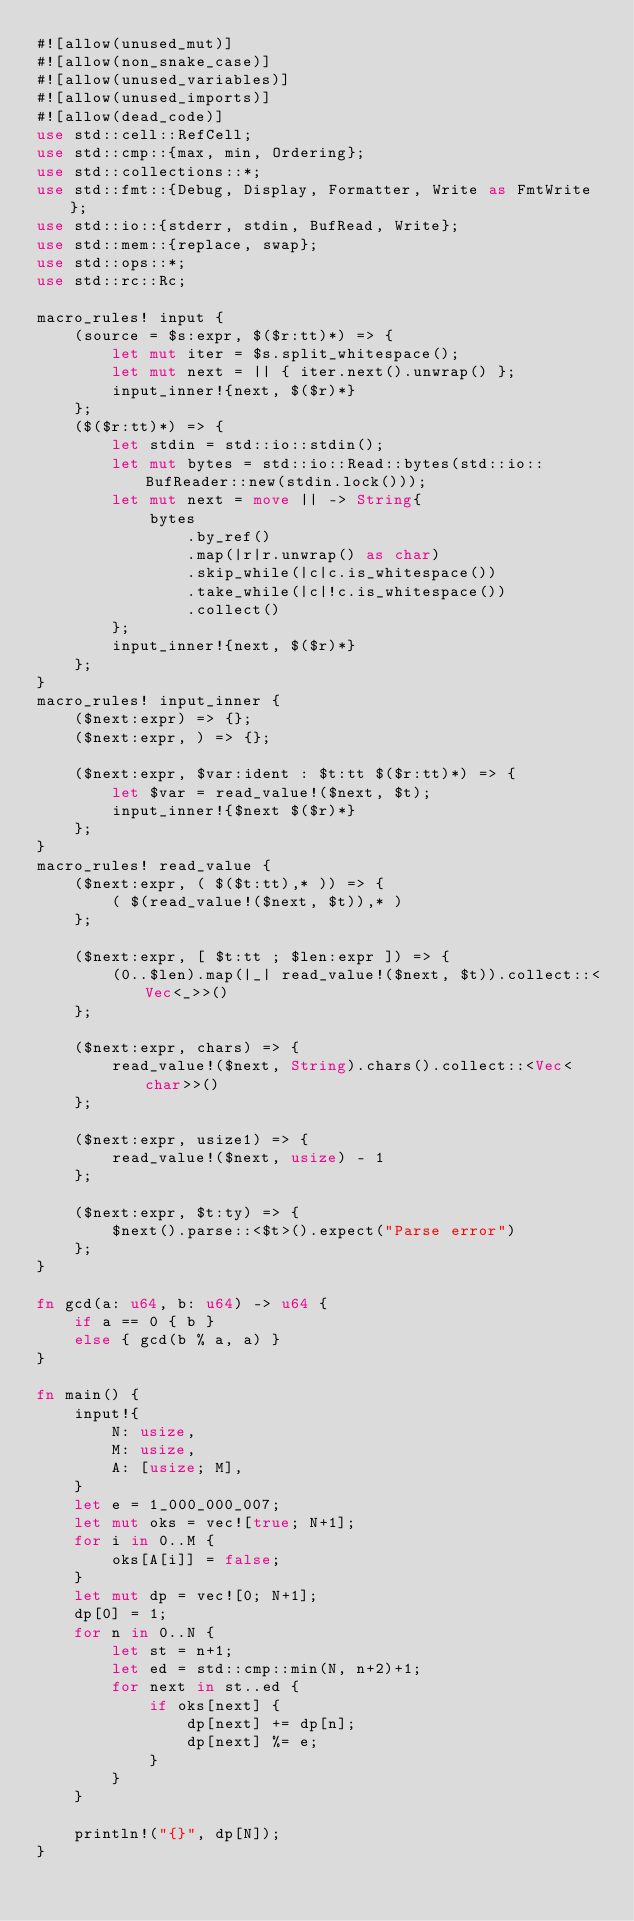Convert code to text. <code><loc_0><loc_0><loc_500><loc_500><_Rust_>#![allow(unused_mut)]
#![allow(non_snake_case)]
#![allow(unused_variables)]
#![allow(unused_imports)]
#![allow(dead_code)]
use std::cell::RefCell;
use std::cmp::{max, min, Ordering};
use std::collections::*;
use std::fmt::{Debug, Display, Formatter, Write as FmtWrite};
use std::io::{stderr, stdin, BufRead, Write};
use std::mem::{replace, swap};
use std::ops::*;
use std::rc::Rc;

macro_rules! input {
    (source = $s:expr, $($r:tt)*) => {
        let mut iter = $s.split_whitespace();
        let mut next = || { iter.next().unwrap() };
        input_inner!{next, $($r)*}
    };
    ($($r:tt)*) => {
        let stdin = std::io::stdin();
        let mut bytes = std::io::Read::bytes(std::io::BufReader::new(stdin.lock()));
        let mut next = move || -> String{
            bytes
                .by_ref()
                .map(|r|r.unwrap() as char)
                .skip_while(|c|c.is_whitespace())
                .take_while(|c|!c.is_whitespace())
                .collect()
        };
        input_inner!{next, $($r)*}
    };
}
macro_rules! input_inner {
    ($next:expr) => {};
    ($next:expr, ) => {};

    ($next:expr, $var:ident : $t:tt $($r:tt)*) => {
        let $var = read_value!($next, $t);
        input_inner!{$next $($r)*}
    };
}
macro_rules! read_value {
    ($next:expr, ( $($t:tt),* )) => {
        ( $(read_value!($next, $t)),* )
    };

    ($next:expr, [ $t:tt ; $len:expr ]) => {
        (0..$len).map(|_| read_value!($next, $t)).collect::<Vec<_>>()
    };

    ($next:expr, chars) => {
        read_value!($next, String).chars().collect::<Vec<char>>()
    };

    ($next:expr, usize1) => {
        read_value!($next, usize) - 1
    };

    ($next:expr, $t:ty) => {
        $next().parse::<$t>().expect("Parse error")
    };
}

fn gcd(a: u64, b: u64) -> u64 {
    if a == 0 { b }
    else { gcd(b % a, a) }
}

fn main() {
    input!{
        N: usize,
        M: usize,
        A: [usize; M],
    }
    let e = 1_000_000_007;
    let mut oks = vec![true; N+1];
    for i in 0..M {
        oks[A[i]] = false;
    }
    let mut dp = vec![0; N+1];
    dp[0] = 1;
    for n in 0..N {
        let st = n+1;
        let ed = std::cmp::min(N, n+2)+1;
        for next in st..ed {
            if oks[next] {
                dp[next] += dp[n];
                dp[next] %= e;
            }
        }
    }

    println!("{}", dp[N]);
}

</code> 